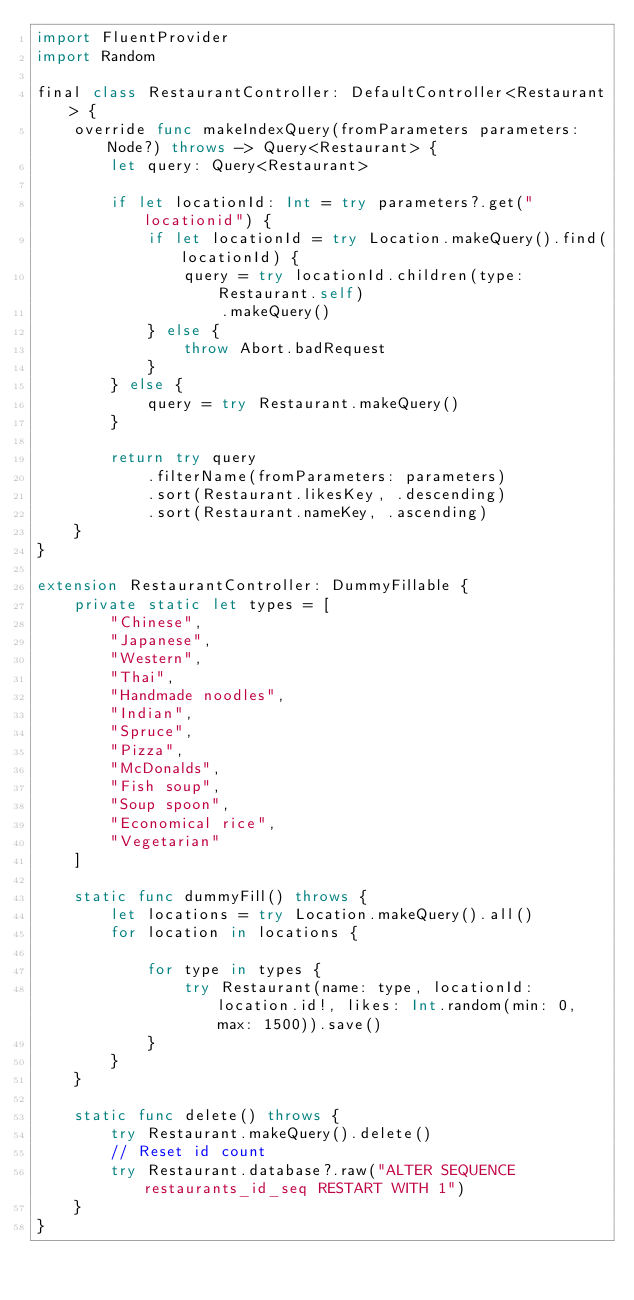Convert code to text. <code><loc_0><loc_0><loc_500><loc_500><_Swift_>import FluentProvider
import Random

final class RestaurantController: DefaultController<Restaurant> {
    override func makeIndexQuery(fromParameters parameters: Node?) throws -> Query<Restaurant> {
        let query: Query<Restaurant>
        
        if let locationId: Int = try parameters?.get("locationid") {
            if let locationId = try Location.makeQuery().find(locationId) {
                query = try locationId.children(type: Restaurant.self)
                    .makeQuery()
            } else {
                throw Abort.badRequest
            }
        } else {
            query = try Restaurant.makeQuery()
        }
        
        return try query
            .filterName(fromParameters: parameters)
            .sort(Restaurant.likesKey, .descending)
            .sort(Restaurant.nameKey, .ascending)
    }
}

extension RestaurantController: DummyFillable {
    private static let types = [
        "Chinese",
        "Japanese",
        "Western",
        "Thai",
        "Handmade noodles",
        "Indian",
        "Spruce",
        "Pizza",
        "McDonalds",
        "Fish soup",
        "Soup spoon",
        "Economical rice",
        "Vegetarian"
    ]
    
    static func dummyFill() throws {
        let locations = try Location.makeQuery().all()
        for location in locations {
            
            for type in types {
                try Restaurant(name: type, locationId: location.id!, likes: Int.random(min: 0, max: 1500)).save()
            }
        }
    }
    
    static func delete() throws {
        try Restaurant.makeQuery().delete()
        // Reset id count
        try Restaurant.database?.raw("ALTER SEQUENCE restaurants_id_seq RESTART WITH 1")
    }
}
</code> 